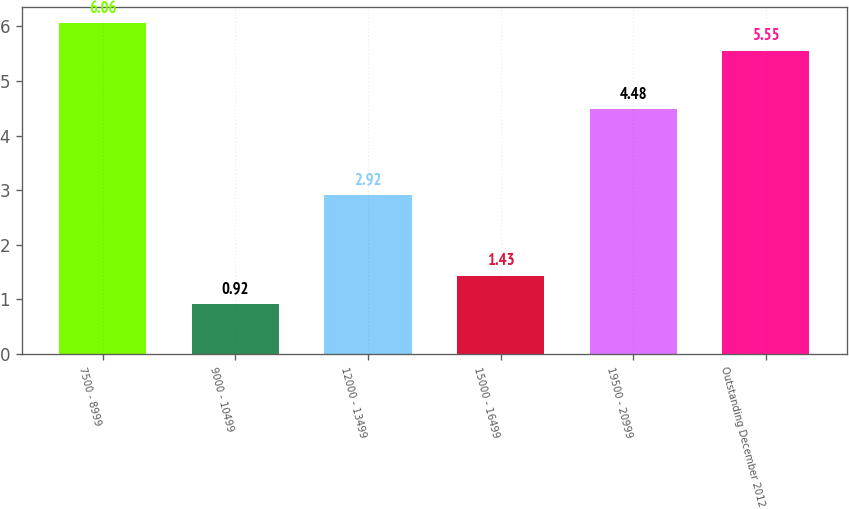Convert chart. <chart><loc_0><loc_0><loc_500><loc_500><bar_chart><fcel>7500 - 8999<fcel>9000 - 10499<fcel>12000 - 13499<fcel>15000 - 16499<fcel>19500 - 20999<fcel>Outstanding December 2012<nl><fcel>6.06<fcel>0.92<fcel>2.92<fcel>1.43<fcel>4.48<fcel>5.55<nl></chart> 